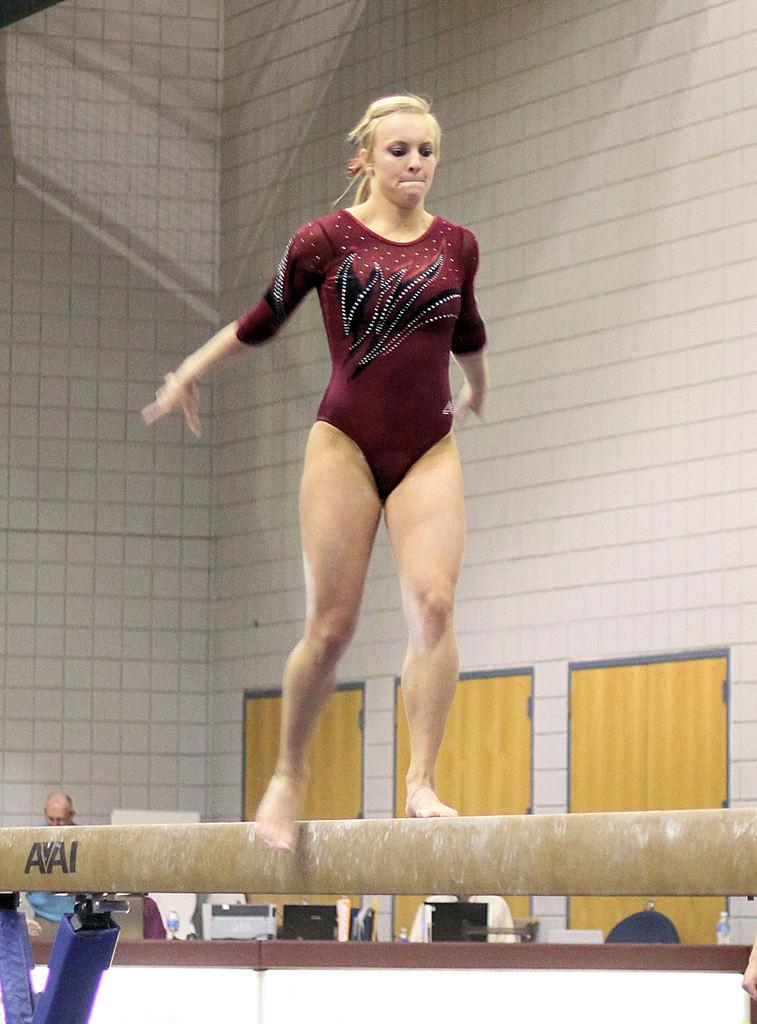What is the woman in the image doing? The woman is standing on a platform in the image. Can you describe the background of the image? In the background of the image, there is a person, bottles, a wall, doors, and some objects. How many doors are visible in the background of the image? There are doors in the background of the image, but the exact number is not specified. What might be the purpose of the platform in the image? The purpose of the platform is not clear from the image, but it could be for a performance or presentation. What type of apparatus is being used by the bears in the image? There are no bears present in the image, and therefore no apparatus is being used by them. 